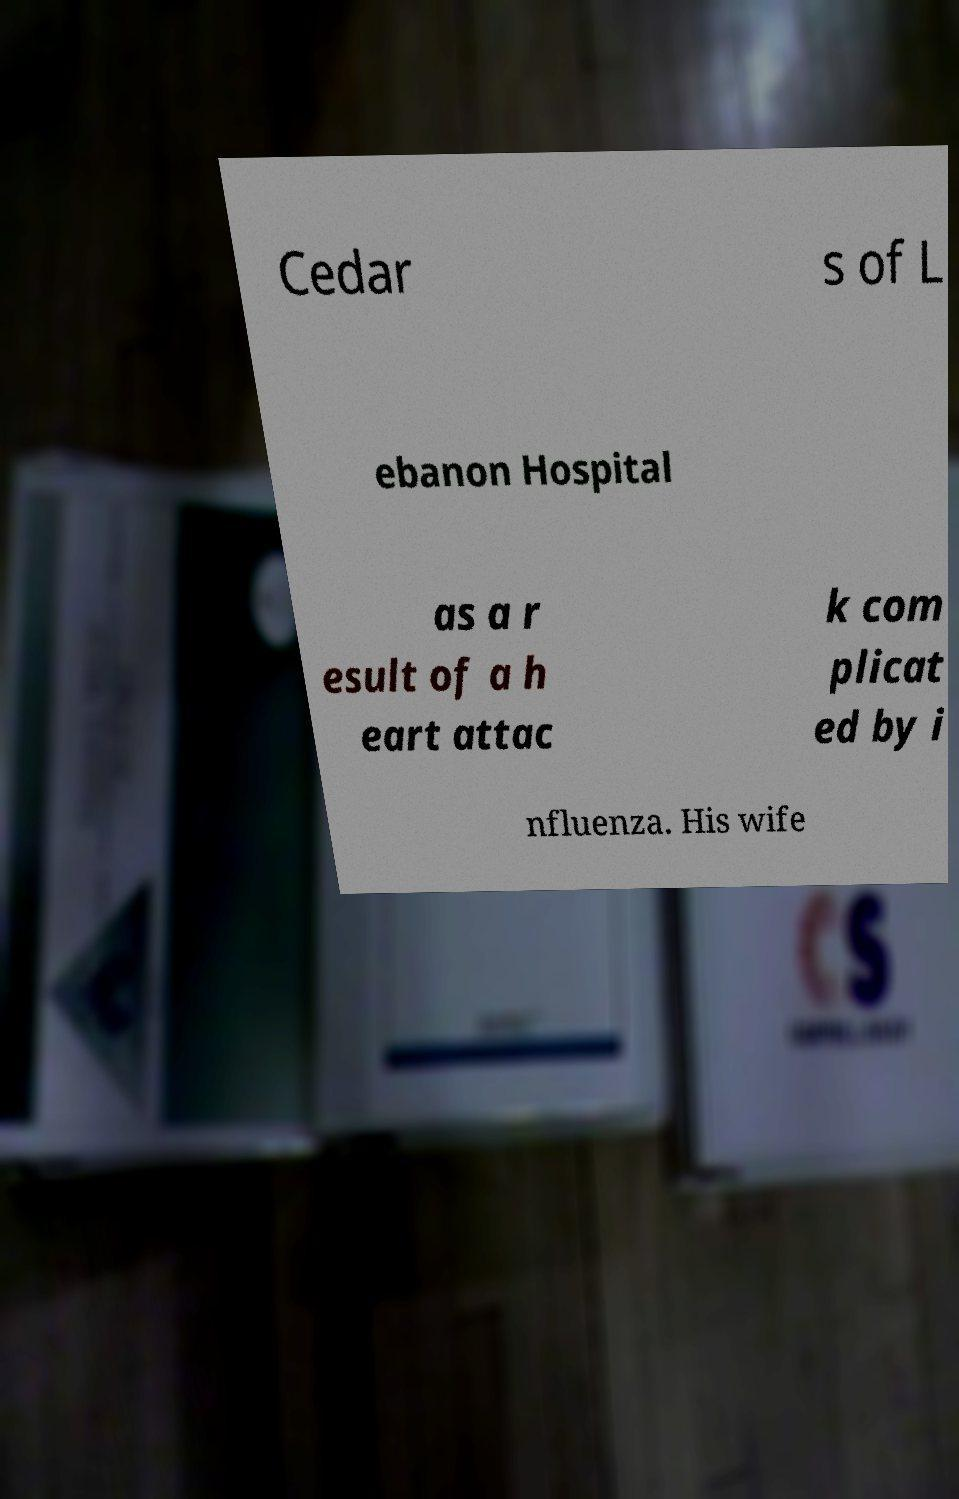Please identify and transcribe the text found in this image. Cedar s of L ebanon Hospital as a r esult of a h eart attac k com plicat ed by i nfluenza. His wife 